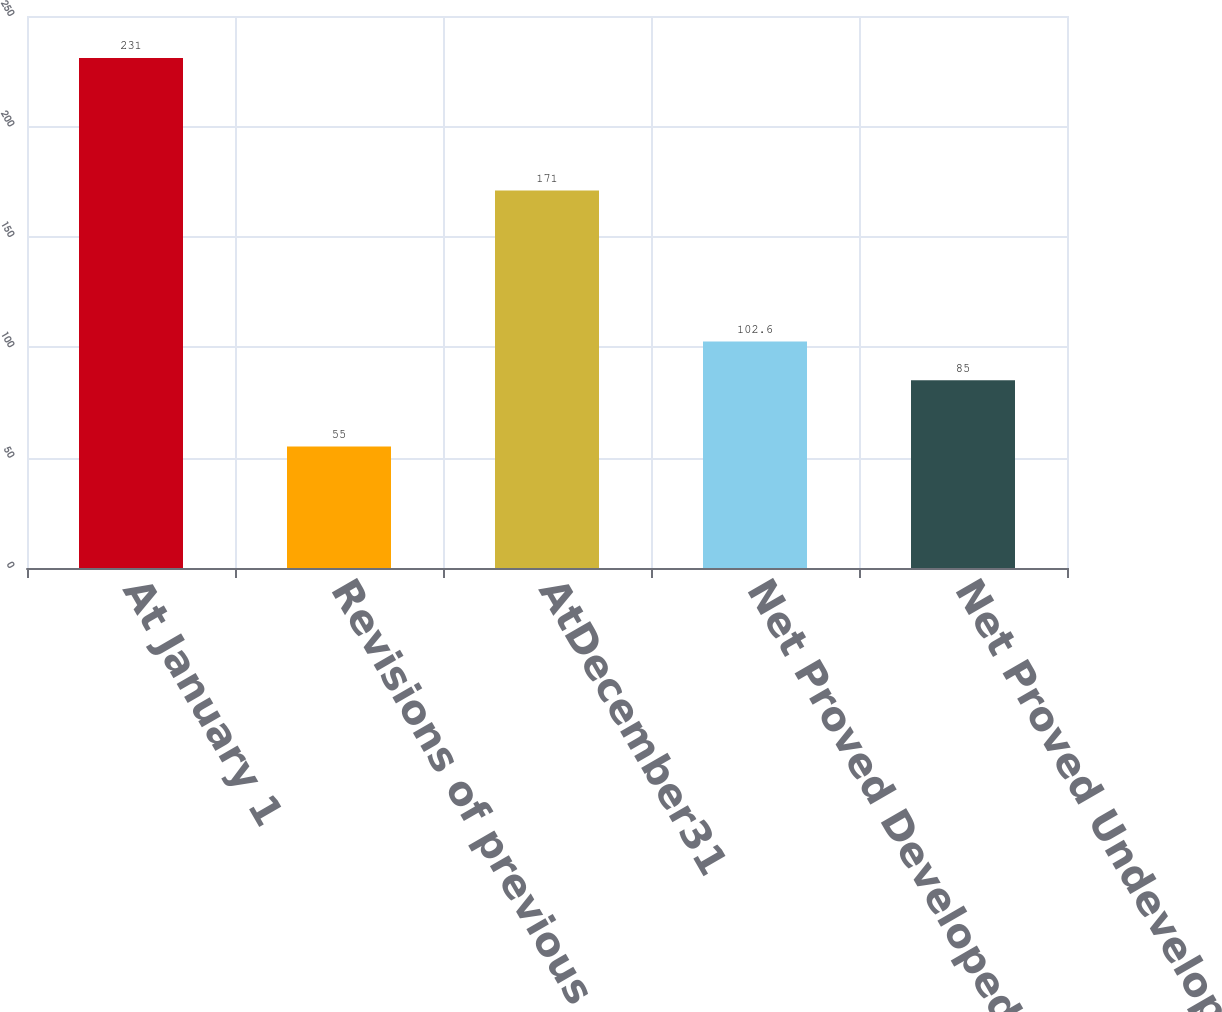<chart> <loc_0><loc_0><loc_500><loc_500><bar_chart><fcel>At January 1<fcel>Revisions of previous<fcel>AtDecember31<fcel>Net Proved Developed Reserves<fcel>Net Proved Undeveloped<nl><fcel>231<fcel>55<fcel>171<fcel>102.6<fcel>85<nl></chart> 